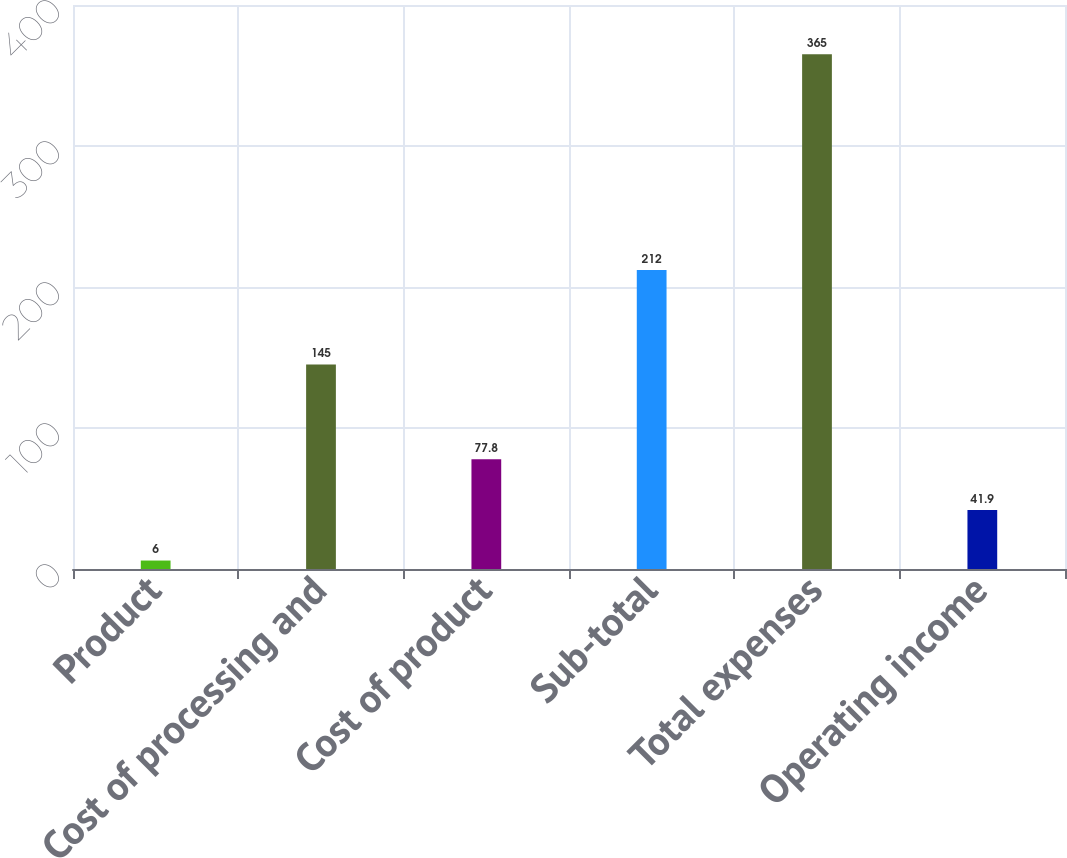Convert chart to OTSL. <chart><loc_0><loc_0><loc_500><loc_500><bar_chart><fcel>Product<fcel>Cost of processing and<fcel>Cost of product<fcel>Sub-total<fcel>Total expenses<fcel>Operating income<nl><fcel>6<fcel>145<fcel>77.8<fcel>212<fcel>365<fcel>41.9<nl></chart> 